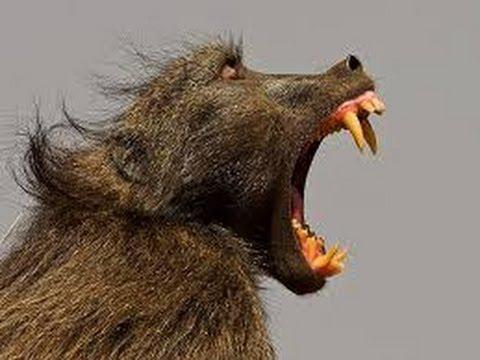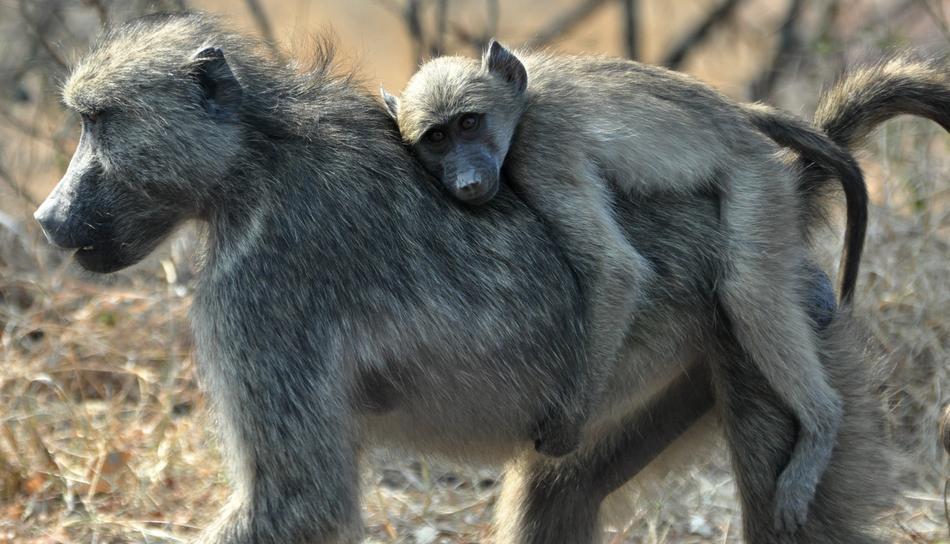The first image is the image on the left, the second image is the image on the right. Considering the images on both sides, is "In one image, two baboons are fighting, at least one with fangs bared, and the tail of the monkey on the left is extended with a bend in it." valid? Answer yes or no. No. The first image is the image on the left, the second image is the image on the right. For the images shown, is this caption "A baboon is carrying its young in one of the images." true? Answer yes or no. Yes. 